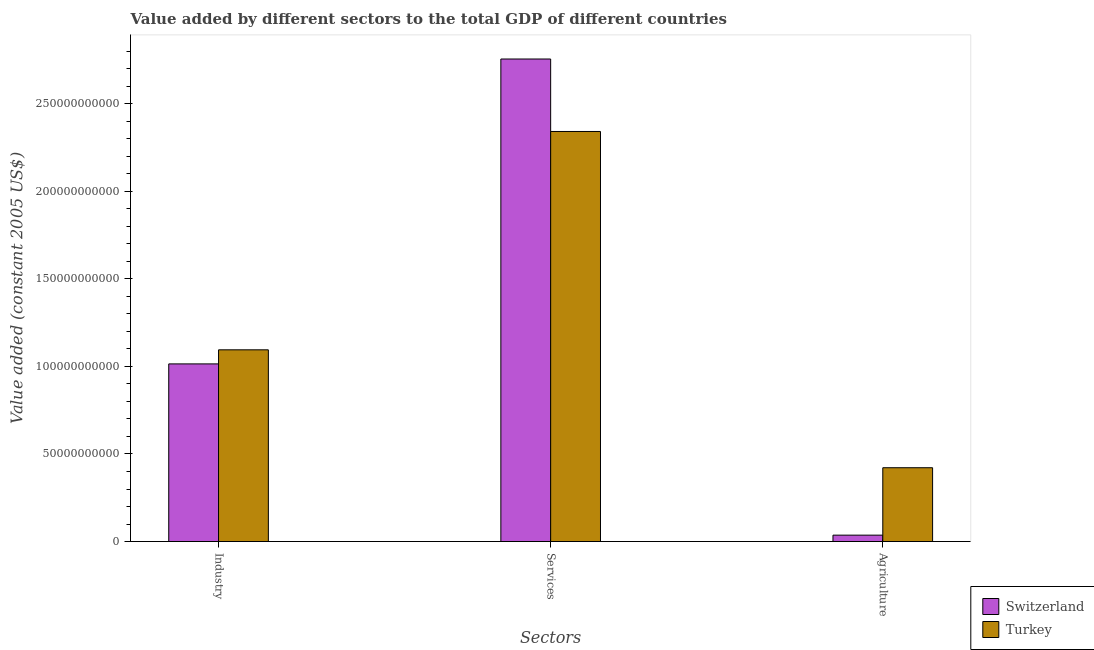How many groups of bars are there?
Offer a terse response. 3. Are the number of bars per tick equal to the number of legend labels?
Provide a succinct answer. Yes. What is the label of the 2nd group of bars from the left?
Your answer should be compact. Services. What is the value added by industrial sector in Turkey?
Your answer should be very brief. 1.09e+11. Across all countries, what is the maximum value added by services?
Make the answer very short. 2.76e+11. Across all countries, what is the minimum value added by services?
Offer a very short reply. 2.34e+11. In which country was the value added by agricultural sector maximum?
Keep it short and to the point. Turkey. In which country was the value added by industrial sector minimum?
Offer a terse response. Switzerland. What is the total value added by agricultural sector in the graph?
Your answer should be very brief. 4.58e+1. What is the difference between the value added by industrial sector in Switzerland and that in Turkey?
Provide a short and direct response. -8.04e+09. What is the difference between the value added by services in Switzerland and the value added by agricultural sector in Turkey?
Your response must be concise. 2.33e+11. What is the average value added by industrial sector per country?
Keep it short and to the point. 1.05e+11. What is the difference between the value added by industrial sector and value added by services in Switzerland?
Offer a very short reply. -1.74e+11. In how many countries, is the value added by industrial sector greater than 210000000000 US$?
Ensure brevity in your answer.  0. What is the ratio of the value added by services in Switzerland to that in Turkey?
Keep it short and to the point. 1.18. What is the difference between the highest and the second highest value added by services?
Your answer should be compact. 4.14e+1. What is the difference between the highest and the lowest value added by agricultural sector?
Give a very brief answer. 3.85e+1. In how many countries, is the value added by services greater than the average value added by services taken over all countries?
Ensure brevity in your answer.  1. Is the sum of the value added by services in Turkey and Switzerland greater than the maximum value added by industrial sector across all countries?
Give a very brief answer. Yes. What does the 1st bar from the left in Services represents?
Your answer should be compact. Switzerland. What does the 1st bar from the right in Industry represents?
Keep it short and to the point. Turkey. Is it the case that in every country, the sum of the value added by industrial sector and value added by services is greater than the value added by agricultural sector?
Keep it short and to the point. Yes. How many bars are there?
Offer a very short reply. 6. Are all the bars in the graph horizontal?
Your answer should be very brief. No. What is the difference between two consecutive major ticks on the Y-axis?
Provide a short and direct response. 5.00e+1. Are the values on the major ticks of Y-axis written in scientific E-notation?
Keep it short and to the point. No. Does the graph contain any zero values?
Your answer should be very brief. No. Where does the legend appear in the graph?
Ensure brevity in your answer.  Bottom right. How many legend labels are there?
Provide a succinct answer. 2. How are the legend labels stacked?
Provide a succinct answer. Vertical. What is the title of the graph?
Your answer should be very brief. Value added by different sectors to the total GDP of different countries. What is the label or title of the X-axis?
Ensure brevity in your answer.  Sectors. What is the label or title of the Y-axis?
Your answer should be compact. Value added (constant 2005 US$). What is the Value added (constant 2005 US$) of Switzerland in Industry?
Provide a succinct answer. 1.01e+11. What is the Value added (constant 2005 US$) in Turkey in Industry?
Provide a short and direct response. 1.09e+11. What is the Value added (constant 2005 US$) in Switzerland in Services?
Give a very brief answer. 2.76e+11. What is the Value added (constant 2005 US$) in Turkey in Services?
Ensure brevity in your answer.  2.34e+11. What is the Value added (constant 2005 US$) of Switzerland in Agriculture?
Provide a short and direct response. 3.66e+09. What is the Value added (constant 2005 US$) in Turkey in Agriculture?
Your answer should be compact. 4.22e+1. Across all Sectors, what is the maximum Value added (constant 2005 US$) of Switzerland?
Provide a succinct answer. 2.76e+11. Across all Sectors, what is the maximum Value added (constant 2005 US$) in Turkey?
Ensure brevity in your answer.  2.34e+11. Across all Sectors, what is the minimum Value added (constant 2005 US$) of Switzerland?
Your answer should be very brief. 3.66e+09. Across all Sectors, what is the minimum Value added (constant 2005 US$) of Turkey?
Offer a very short reply. 4.22e+1. What is the total Value added (constant 2005 US$) in Switzerland in the graph?
Your answer should be very brief. 3.81e+11. What is the total Value added (constant 2005 US$) in Turkey in the graph?
Keep it short and to the point. 3.86e+11. What is the difference between the Value added (constant 2005 US$) in Switzerland in Industry and that in Services?
Your response must be concise. -1.74e+11. What is the difference between the Value added (constant 2005 US$) of Turkey in Industry and that in Services?
Make the answer very short. -1.25e+11. What is the difference between the Value added (constant 2005 US$) in Switzerland in Industry and that in Agriculture?
Your answer should be compact. 9.78e+1. What is the difference between the Value added (constant 2005 US$) in Turkey in Industry and that in Agriculture?
Your response must be concise. 6.73e+1. What is the difference between the Value added (constant 2005 US$) in Switzerland in Services and that in Agriculture?
Provide a succinct answer. 2.72e+11. What is the difference between the Value added (constant 2005 US$) in Turkey in Services and that in Agriculture?
Your response must be concise. 1.92e+11. What is the difference between the Value added (constant 2005 US$) of Switzerland in Industry and the Value added (constant 2005 US$) of Turkey in Services?
Make the answer very short. -1.33e+11. What is the difference between the Value added (constant 2005 US$) in Switzerland in Industry and the Value added (constant 2005 US$) in Turkey in Agriculture?
Your answer should be very brief. 5.93e+1. What is the difference between the Value added (constant 2005 US$) in Switzerland in Services and the Value added (constant 2005 US$) in Turkey in Agriculture?
Make the answer very short. 2.33e+11. What is the average Value added (constant 2005 US$) of Switzerland per Sectors?
Your answer should be compact. 1.27e+11. What is the average Value added (constant 2005 US$) in Turkey per Sectors?
Offer a terse response. 1.29e+11. What is the difference between the Value added (constant 2005 US$) of Switzerland and Value added (constant 2005 US$) of Turkey in Industry?
Offer a very short reply. -8.04e+09. What is the difference between the Value added (constant 2005 US$) of Switzerland and Value added (constant 2005 US$) of Turkey in Services?
Provide a succinct answer. 4.14e+1. What is the difference between the Value added (constant 2005 US$) in Switzerland and Value added (constant 2005 US$) in Turkey in Agriculture?
Make the answer very short. -3.85e+1. What is the ratio of the Value added (constant 2005 US$) of Switzerland in Industry to that in Services?
Ensure brevity in your answer.  0.37. What is the ratio of the Value added (constant 2005 US$) in Turkey in Industry to that in Services?
Offer a very short reply. 0.47. What is the ratio of the Value added (constant 2005 US$) of Switzerland in Industry to that in Agriculture?
Offer a terse response. 27.71. What is the ratio of the Value added (constant 2005 US$) of Turkey in Industry to that in Agriculture?
Offer a very short reply. 2.6. What is the ratio of the Value added (constant 2005 US$) of Switzerland in Services to that in Agriculture?
Your answer should be very brief. 75.28. What is the ratio of the Value added (constant 2005 US$) of Turkey in Services to that in Agriculture?
Give a very brief answer. 5.55. What is the difference between the highest and the second highest Value added (constant 2005 US$) of Switzerland?
Offer a terse response. 1.74e+11. What is the difference between the highest and the second highest Value added (constant 2005 US$) in Turkey?
Your answer should be compact. 1.25e+11. What is the difference between the highest and the lowest Value added (constant 2005 US$) of Switzerland?
Offer a terse response. 2.72e+11. What is the difference between the highest and the lowest Value added (constant 2005 US$) in Turkey?
Offer a terse response. 1.92e+11. 